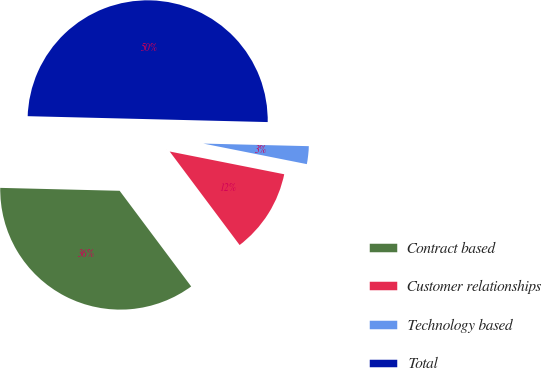Convert chart. <chart><loc_0><loc_0><loc_500><loc_500><pie_chart><fcel>Contract based<fcel>Customer relationships<fcel>Technology based<fcel>Total<nl><fcel>35.61%<fcel>11.66%<fcel>2.73%<fcel>50.0%<nl></chart> 